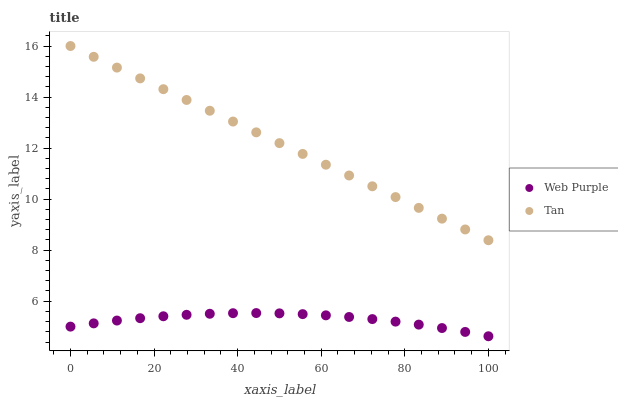Does Web Purple have the minimum area under the curve?
Answer yes or no. Yes. Does Tan have the maximum area under the curve?
Answer yes or no. Yes. Does Tan have the minimum area under the curve?
Answer yes or no. No. Is Tan the smoothest?
Answer yes or no. Yes. Is Web Purple the roughest?
Answer yes or no. Yes. Is Tan the roughest?
Answer yes or no. No. Does Web Purple have the lowest value?
Answer yes or no. Yes. Does Tan have the lowest value?
Answer yes or no. No. Does Tan have the highest value?
Answer yes or no. Yes. Is Web Purple less than Tan?
Answer yes or no. Yes. Is Tan greater than Web Purple?
Answer yes or no. Yes. Does Web Purple intersect Tan?
Answer yes or no. No. 